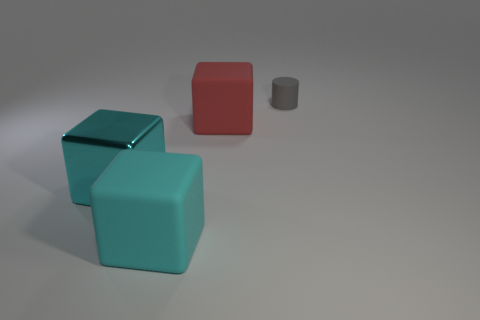Add 3 red metallic cylinders. How many objects exist? 7 Subtract all cylinders. How many objects are left? 3 Add 2 cyan metal cubes. How many cyan metal cubes exist? 3 Subtract 0 brown spheres. How many objects are left? 4 Subtract all red metal cylinders. Subtract all large red matte blocks. How many objects are left? 3 Add 3 red matte blocks. How many red matte blocks are left? 4 